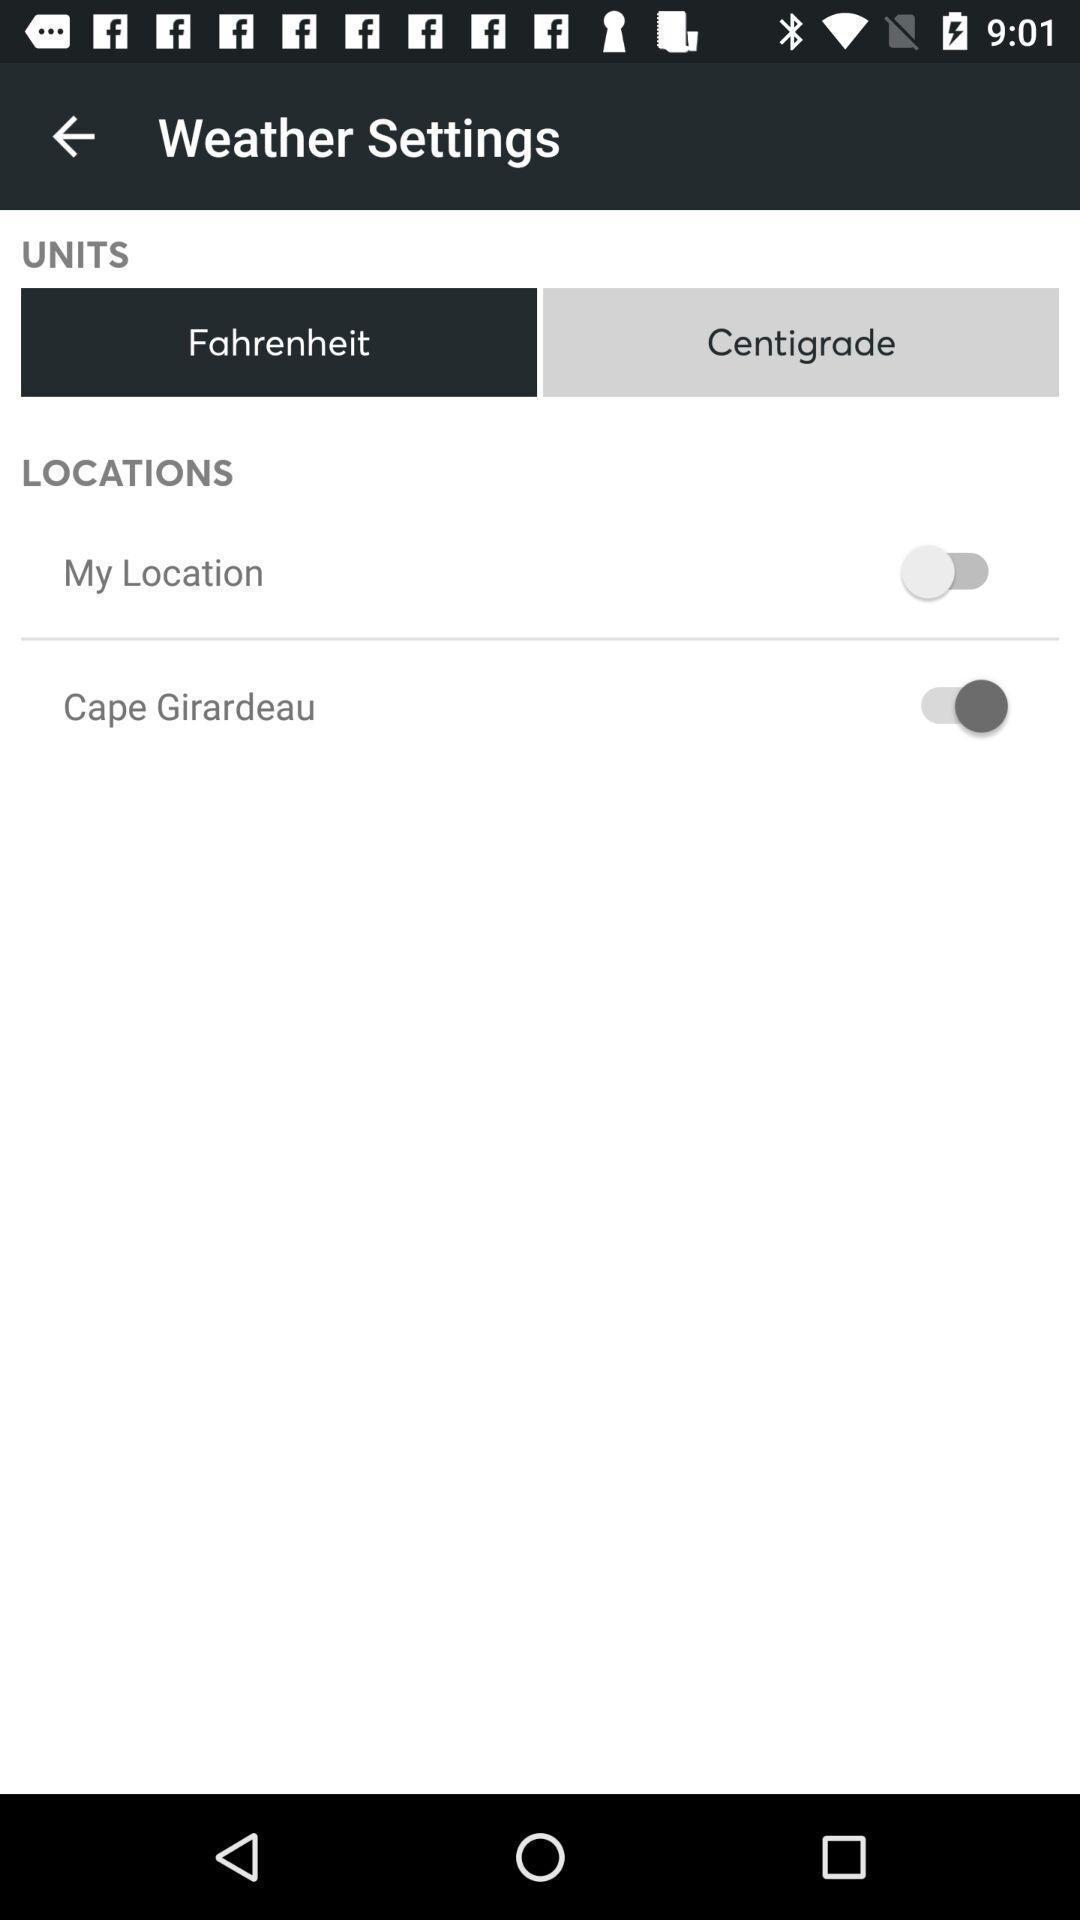Tell me what you see in this picture. Screen displaying the weather settings page. 